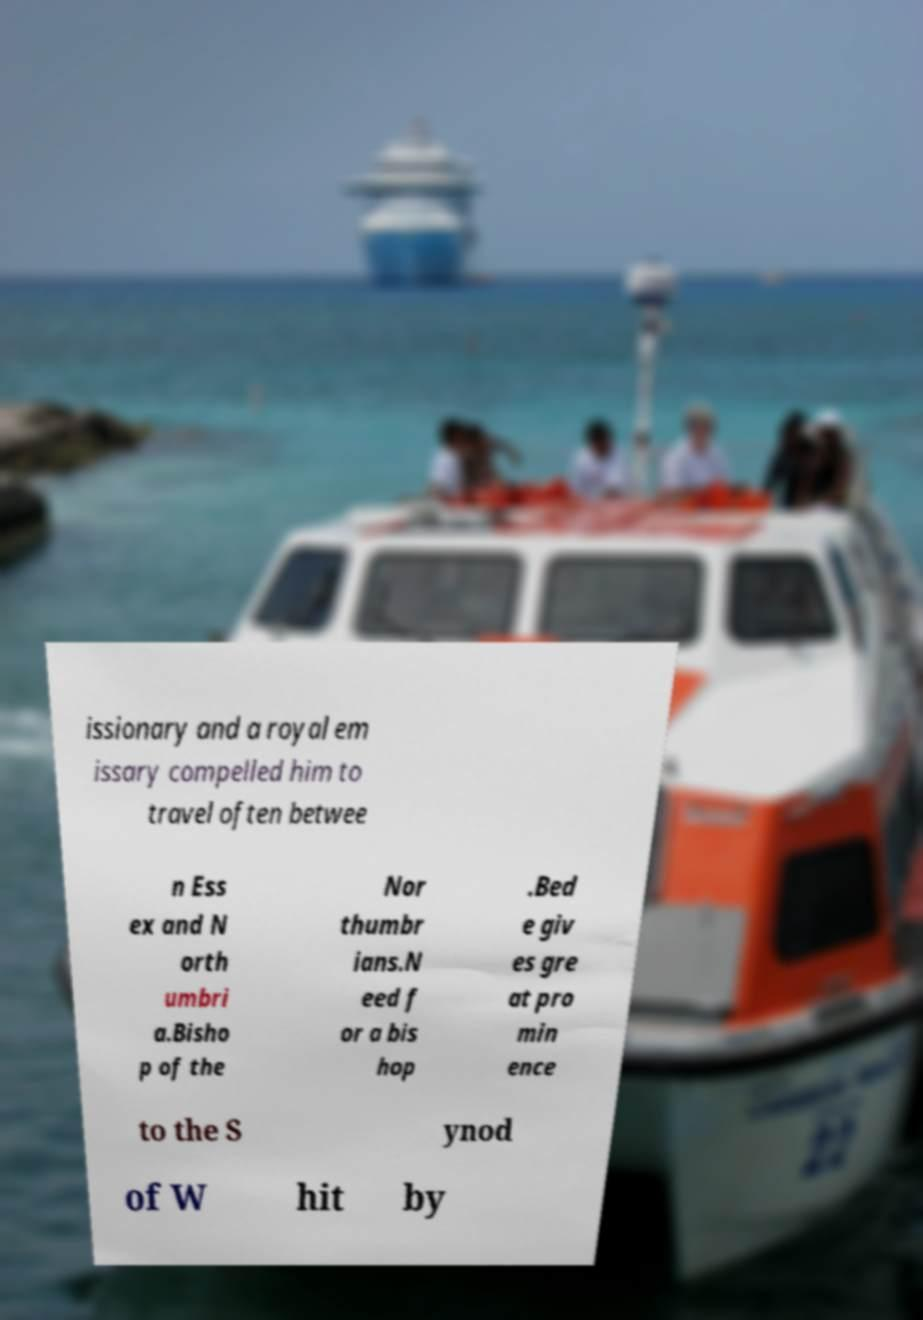Please read and relay the text visible in this image. What does it say? issionary and a royal em issary compelled him to travel often betwee n Ess ex and N orth umbri a.Bisho p of the Nor thumbr ians.N eed f or a bis hop .Bed e giv es gre at pro min ence to the S ynod of W hit by 